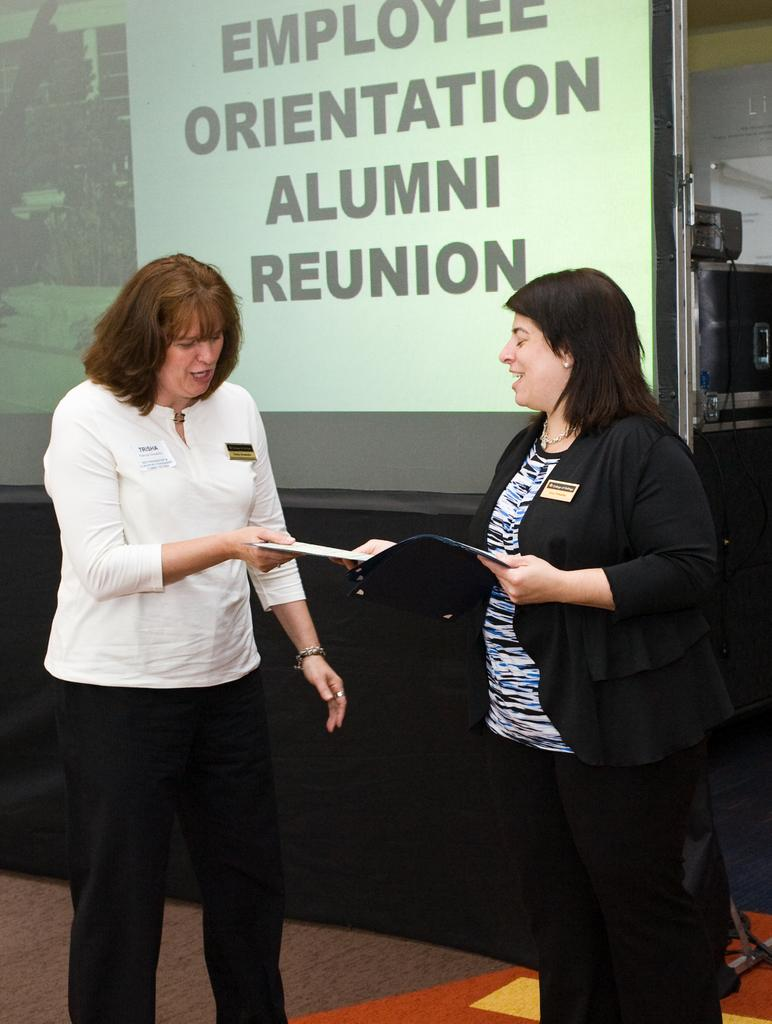How many people are in the image? There are two ladies in the image. What are the ladies doing in the image? The ladies are standing and talking with each other. What object are the ladies holding in the image? The ladies are holding a book. What can be seen in the background of the image? There is a screen in the background of the image. Can you see any amusement park rides in the image? There is no amusement park or rides present in the image. Are the ladies skating in the image? The ladies are not skating in the image; they are standing and talking with each other. 